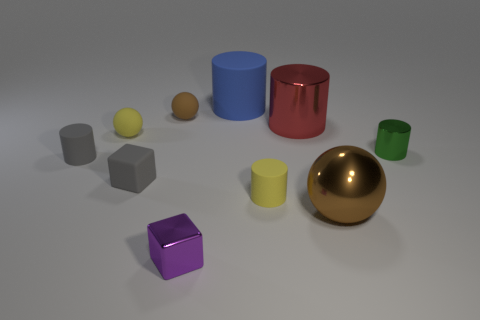Subtract all red cylinders. How many cylinders are left? 4 Subtract all blue cylinders. Subtract all blue cubes. How many cylinders are left? 4 Subtract all blocks. How many objects are left? 8 Add 6 gray rubber cubes. How many gray rubber cubes are left? 7 Add 4 purple metallic things. How many purple metallic things exist? 5 Subtract 2 brown spheres. How many objects are left? 8 Subtract all gray metallic balls. Subtract all small spheres. How many objects are left? 8 